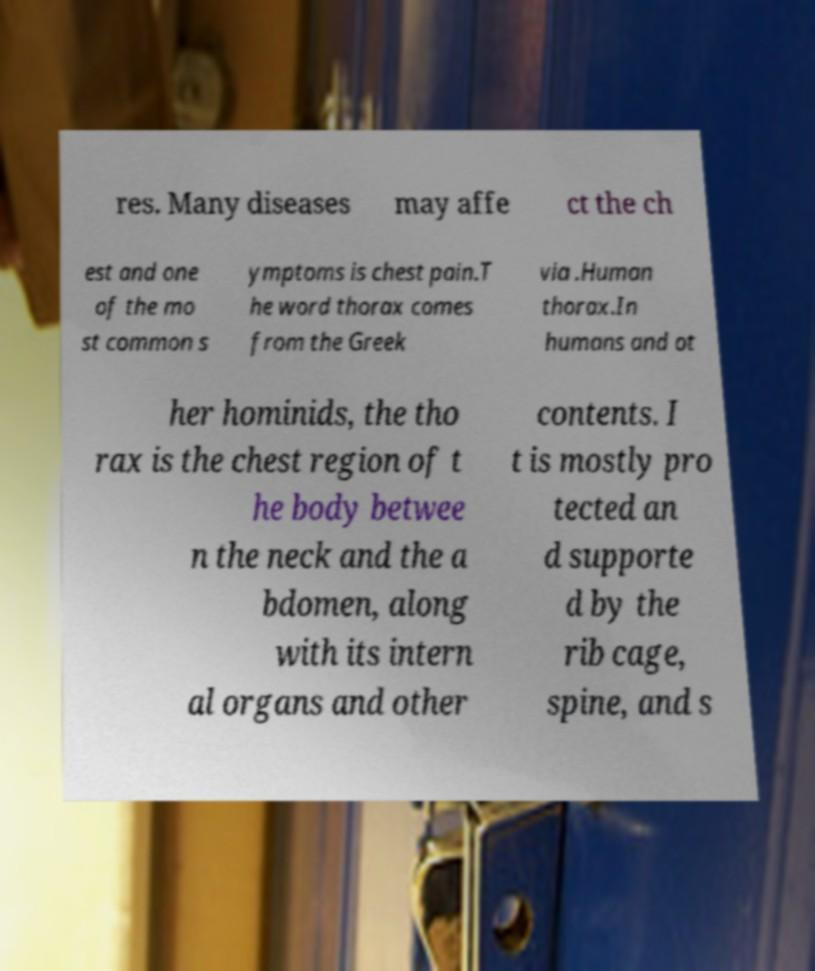I need the written content from this picture converted into text. Can you do that? res. Many diseases may affe ct the ch est and one of the mo st common s ymptoms is chest pain.T he word thorax comes from the Greek via .Human thorax.In humans and ot her hominids, the tho rax is the chest region of t he body betwee n the neck and the a bdomen, along with its intern al organs and other contents. I t is mostly pro tected an d supporte d by the rib cage, spine, and s 